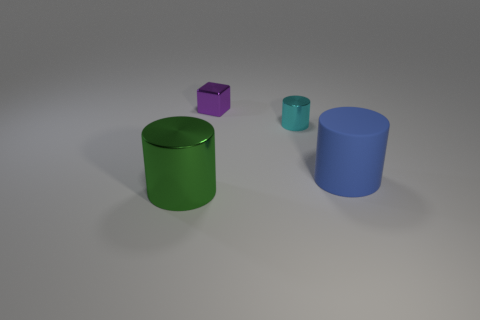There is a blue thing that is the same shape as the cyan shiny thing; what is it made of?
Your response must be concise. Rubber. Are there fewer large matte objects in front of the large green metallic cylinder than small cyan cylinders?
Keep it short and to the point. Yes. There is a large thing that is behind the green shiny cylinder; is it the same shape as the purple shiny thing?
Offer a very short reply. No. Is there anything else of the same color as the large rubber cylinder?
Offer a terse response. No. What is the size of the cube that is made of the same material as the big green cylinder?
Provide a short and direct response. Small. There is a large thing that is behind the large object that is to the left of the small metal thing that is in front of the tiny purple cube; what is it made of?
Provide a succinct answer. Rubber. Is the number of tiny red things less than the number of large green metal cylinders?
Provide a short and direct response. Yes. Are the tiny cyan cylinder and the tiny block made of the same material?
Your answer should be very brief. Yes. Do the large thing that is to the right of the tiny purple cube and the block have the same color?
Keep it short and to the point. No. There is a tiny shiny thing that is behind the small metal cylinder; how many small shiny cylinders are in front of it?
Offer a very short reply. 1. 